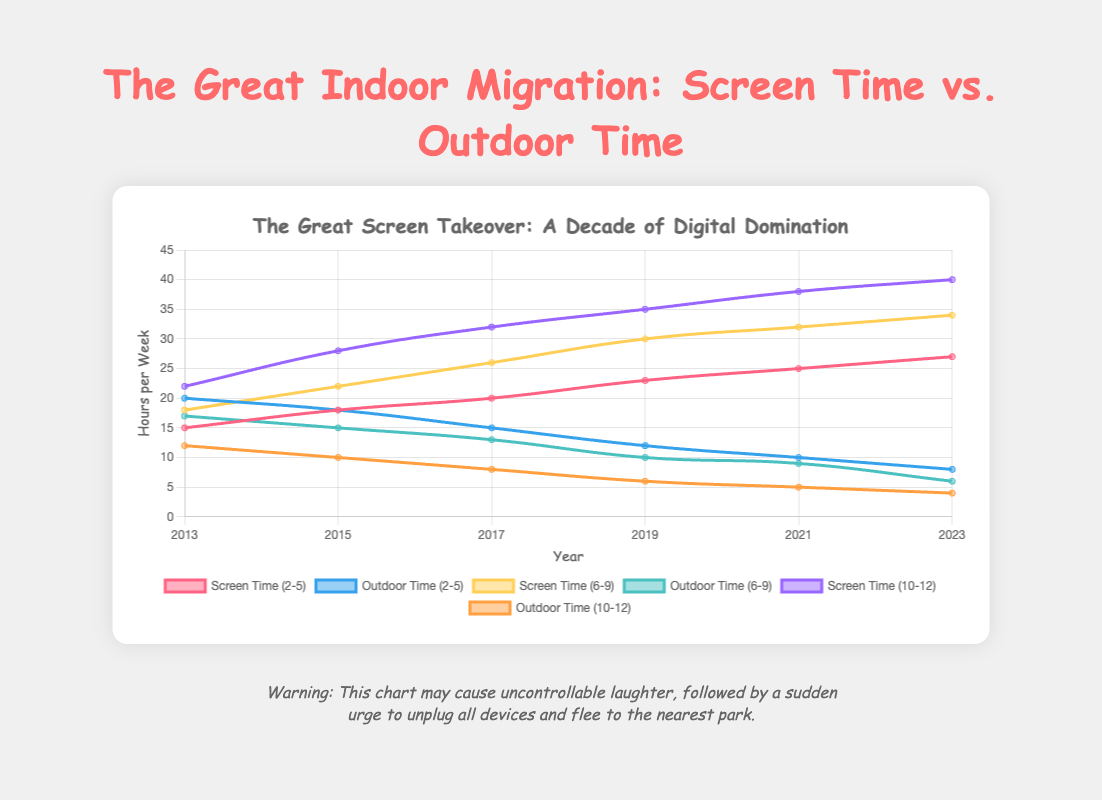What is the total screen time for children aged 2-5 in 2023? According to the chart, the screen time for children aged 2-5 in 2023 is shown on the corresponding line.
Answer: 27 hours per week What is the difference in outdoor time between 2-5-year-olds and 10-12-year-olds in 2021? For 2-5-year-olds, the outdoor time in 2021 is 10 hours per week. For 10-12-year-olds, it is 5 hours per week. Subtracting these values gives the difference.
Answer: 5 hours per week Which age group had the highest screen time in 2019? By observing the screen time lines for all age groups in 2019, the group with the highest value can be identified.
Answer: 10-12 Over the decade, did the screen time for 6-9-year-olds ever decrease from one year to the next, and if so, when? By following the screen time line for 6-9-year-olds, check for any segment where the line shows a downward trend.
Answer: No, it always increased What is the average outdoor time across all age groups in 2017? Calculate the total outdoor time for each age group in 2017 (15 for 2-5, 13 for 6-9, 8 for 10-12) and find the average by dividing the sum by the number of age groups (36/3).
Answer: 12 hours per week By how much did the screen time increase for the 10-12 age group from 2013 to 2023? Subtract the screen time in 2013 (22 hours per week) from the screen time in 2023 (40 hours per week) for the 10-12 age group.
Answer: 18 hours per week In which year did the 2-5 age group have equal screen time and outdoor time? Find the point where the lines for screen time and outdoor time for the 2-5 age group intersect or match.
Answer: 2015 Compare the trends between screen time and outdoor time for the 6-9 age group from 2013 to 2023. Follow the screen time and outdoor time lines for 6-9 from 2013 to 2023. Screen time increases steadily while outdoor time decreases.
Answer: Screen time increases, outdoor time decreases What is the lowest outdoor time value observed for any age group, and in what year? Look for the lowest point on the outdoor time lines, which corresponds to the lowest value.
Answer: 4 hours per week, 2023 Determine the total outdoor time for all age groups combined in 2023. Add the outdoor time values for each age group in 2023 (8 for 2-5, 6 for 6-9, 4 for 10-12) to get the total.
Answer: 18 hours per week 